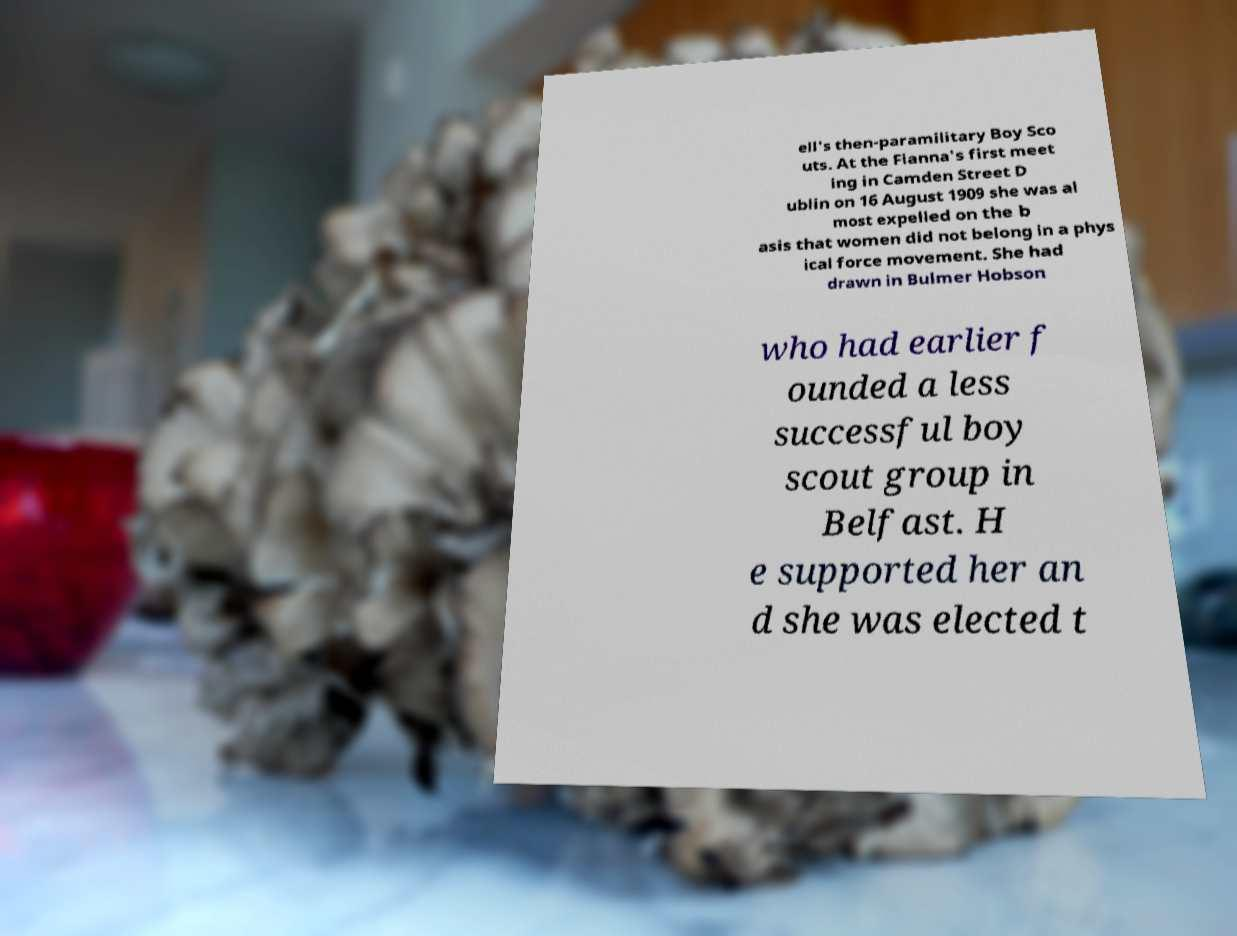I need the written content from this picture converted into text. Can you do that? ell's then-paramilitary Boy Sco uts. At the Fianna's first meet ing in Camden Street D ublin on 16 August 1909 she was al most expelled on the b asis that women did not belong in a phys ical force movement. She had drawn in Bulmer Hobson who had earlier f ounded a less successful boy scout group in Belfast. H e supported her an d she was elected t 